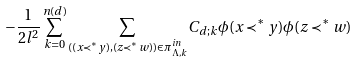<formula> <loc_0><loc_0><loc_500><loc_500>- \frac { 1 } { 2 l ^ { 2 } } \sum _ { k = 0 } ^ { n ( d ) } \sum _ { ( ( x \prec ^ { * } y ) , ( z \prec ^ { * } w ) ) \in \pi _ { \Lambda , k } ^ { i n } } C _ { d ; k } \phi ( x \prec ^ { * } y ) \phi ( z \prec ^ { * } w )</formula> 